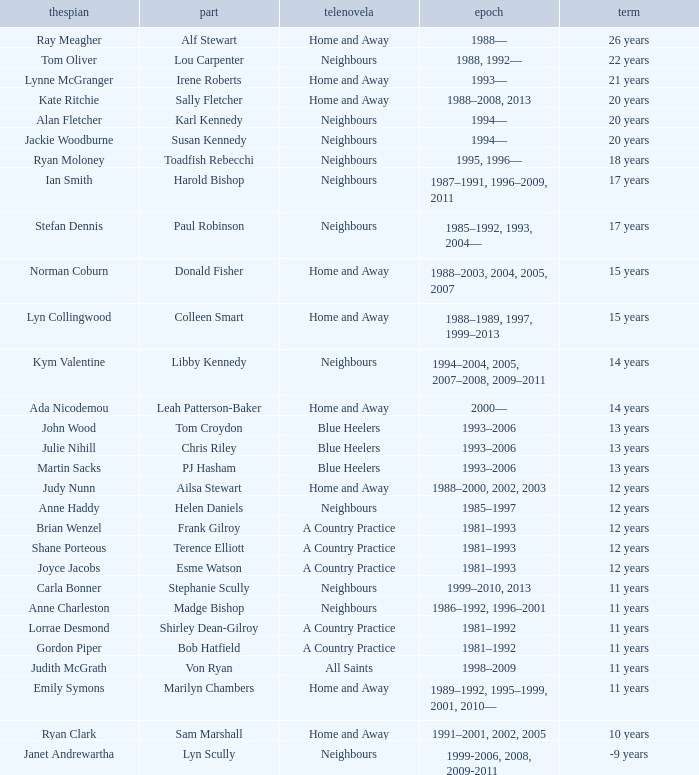Help me parse the entirety of this table. {'header': ['thespian', 'part', 'telenovela', 'epoch', 'term'], 'rows': [['Ray Meagher', 'Alf Stewart', 'Home and Away', '1988—', '26 years'], ['Tom Oliver', 'Lou Carpenter', 'Neighbours', '1988, 1992—', '22 years'], ['Lynne McGranger', 'Irene Roberts', 'Home and Away', '1993—', '21 years'], ['Kate Ritchie', 'Sally Fletcher', 'Home and Away', '1988–2008, 2013', '20 years'], ['Alan Fletcher', 'Karl Kennedy', 'Neighbours', '1994—', '20 years'], ['Jackie Woodburne', 'Susan Kennedy', 'Neighbours', '1994—', '20 years'], ['Ryan Moloney', 'Toadfish Rebecchi', 'Neighbours', '1995, 1996—', '18 years'], ['Ian Smith', 'Harold Bishop', 'Neighbours', '1987–1991, 1996–2009, 2011', '17 years'], ['Stefan Dennis', 'Paul Robinson', 'Neighbours', '1985–1992, 1993, 2004—', '17 years'], ['Norman Coburn', 'Donald Fisher', 'Home and Away', '1988–2003, 2004, 2005, 2007', '15 years'], ['Lyn Collingwood', 'Colleen Smart', 'Home and Away', '1988–1989, 1997, 1999–2013', '15 years'], ['Kym Valentine', 'Libby Kennedy', 'Neighbours', '1994–2004, 2005, 2007–2008, 2009–2011', '14 years'], ['Ada Nicodemou', 'Leah Patterson-Baker', 'Home and Away', '2000—', '14 years'], ['John Wood', 'Tom Croydon', 'Blue Heelers', '1993–2006', '13 years'], ['Julie Nihill', 'Chris Riley', 'Blue Heelers', '1993–2006', '13 years'], ['Martin Sacks', 'PJ Hasham', 'Blue Heelers', '1993–2006', '13 years'], ['Judy Nunn', 'Ailsa Stewart', 'Home and Away', '1988–2000, 2002, 2003', '12 years'], ['Anne Haddy', 'Helen Daniels', 'Neighbours', '1985–1997', '12 years'], ['Brian Wenzel', 'Frank Gilroy', 'A Country Practice', '1981–1993', '12 years'], ['Shane Porteous', 'Terence Elliott', 'A Country Practice', '1981–1993', '12 years'], ['Joyce Jacobs', 'Esme Watson', 'A Country Practice', '1981–1993', '12 years'], ['Carla Bonner', 'Stephanie Scully', 'Neighbours', '1999–2010, 2013', '11 years'], ['Anne Charleston', 'Madge Bishop', 'Neighbours', '1986–1992, 1996–2001', '11 years'], ['Lorrae Desmond', 'Shirley Dean-Gilroy', 'A Country Practice', '1981–1992', '11 years'], ['Gordon Piper', 'Bob Hatfield', 'A Country Practice', '1981–1992', '11 years'], ['Judith McGrath', 'Von Ryan', 'All Saints', '1998–2009', '11 years'], ['Emily Symons', 'Marilyn Chambers', 'Home and Away', '1989–1992, 1995–1999, 2001, 2010—', '11 years'], ['Ryan Clark', 'Sam Marshall', 'Home and Away', '1991–2001, 2002, 2005', '10 years'], ['Janet Andrewartha', 'Lyn Scully', 'Neighbours', '1999-2006, 2008, 2009-2011', '-9 years']]} Which persona was represented by the same thespian for 12 years on neighbours? Helen Daniels. 